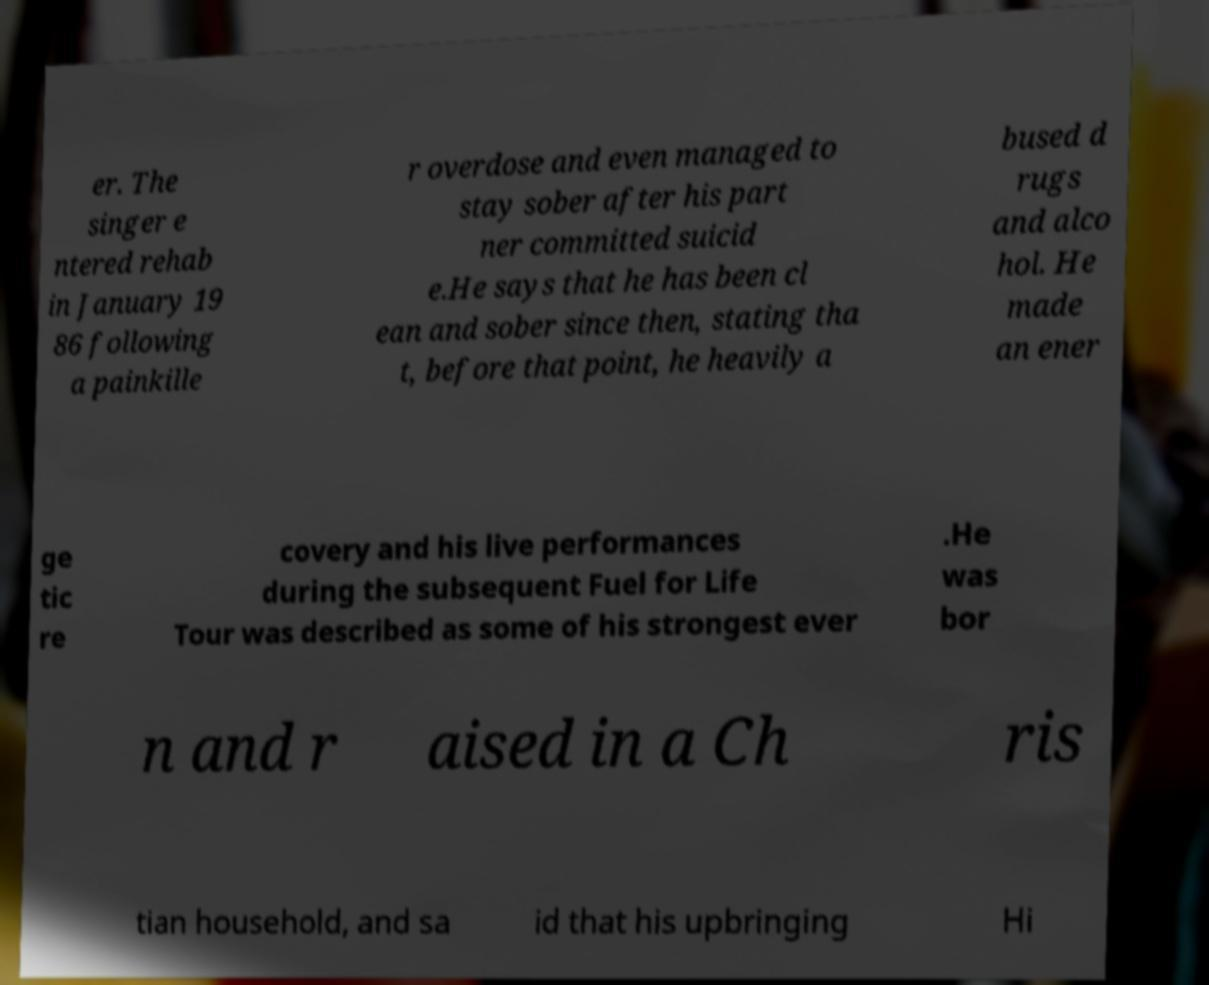Could you extract and type out the text from this image? er. The singer e ntered rehab in January 19 86 following a painkille r overdose and even managed to stay sober after his part ner committed suicid e.He says that he has been cl ean and sober since then, stating tha t, before that point, he heavily a bused d rugs and alco hol. He made an ener ge tic re covery and his live performances during the subsequent Fuel for Life Tour was described as some of his strongest ever .He was bor n and r aised in a Ch ris tian household, and sa id that his upbringing Hi 